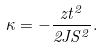<formula> <loc_0><loc_0><loc_500><loc_500>\kappa = - \frac { z t ^ { 2 } } { 2 J S ^ { 2 } } .</formula> 